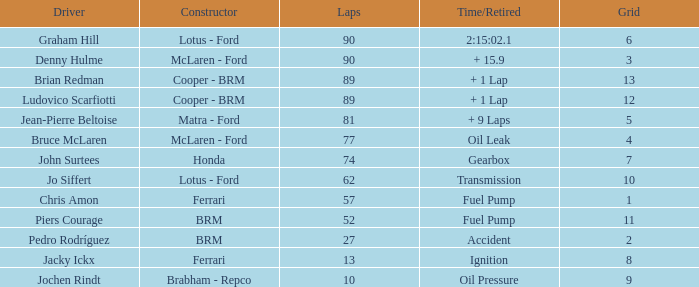What is the elapsed time/retired when the laps equal 52? Fuel Pump. 